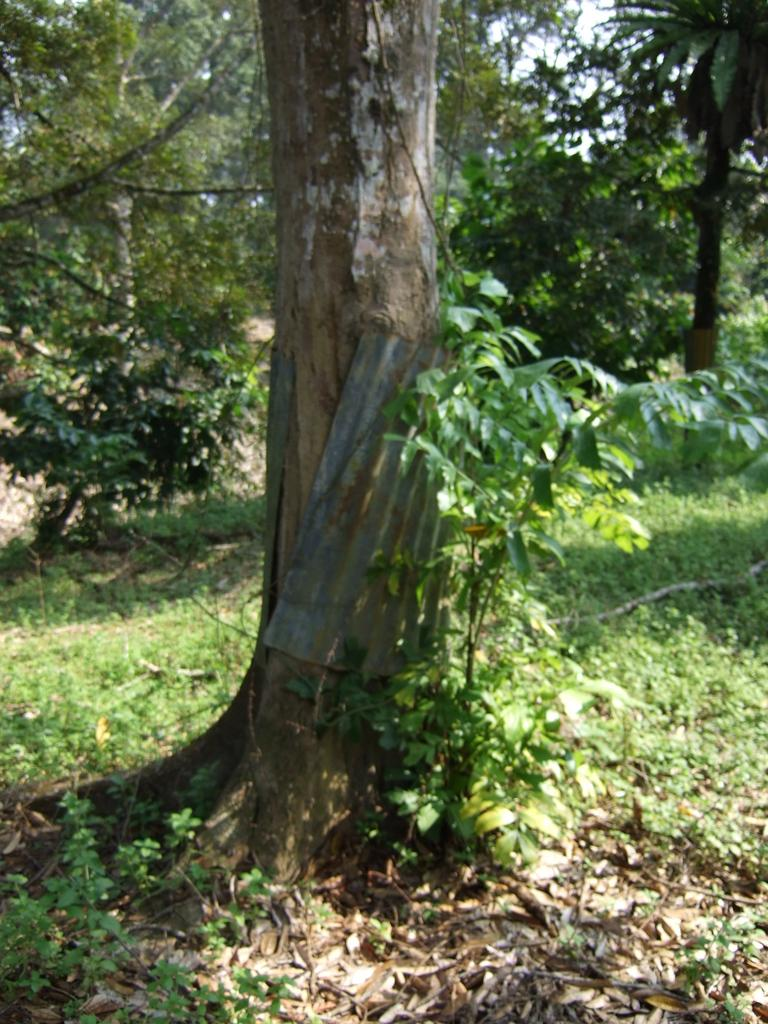What is located on the ground in the foreground of the image? There are plants on the ground in the foreground of the image. What else can be seen in the foreground of the image? There is a tree trunk in the middle of the foreground, and a metal sheet is present around the tree trunk. What is visible in the background of the image? There are trees and the sky in the background of the image. What type of underwear is hanging on the tree trunk in the image? There is no underwear present in the image; it features plants, a tree trunk, and a metal sheet in the foreground, with trees and the sky in the background. 